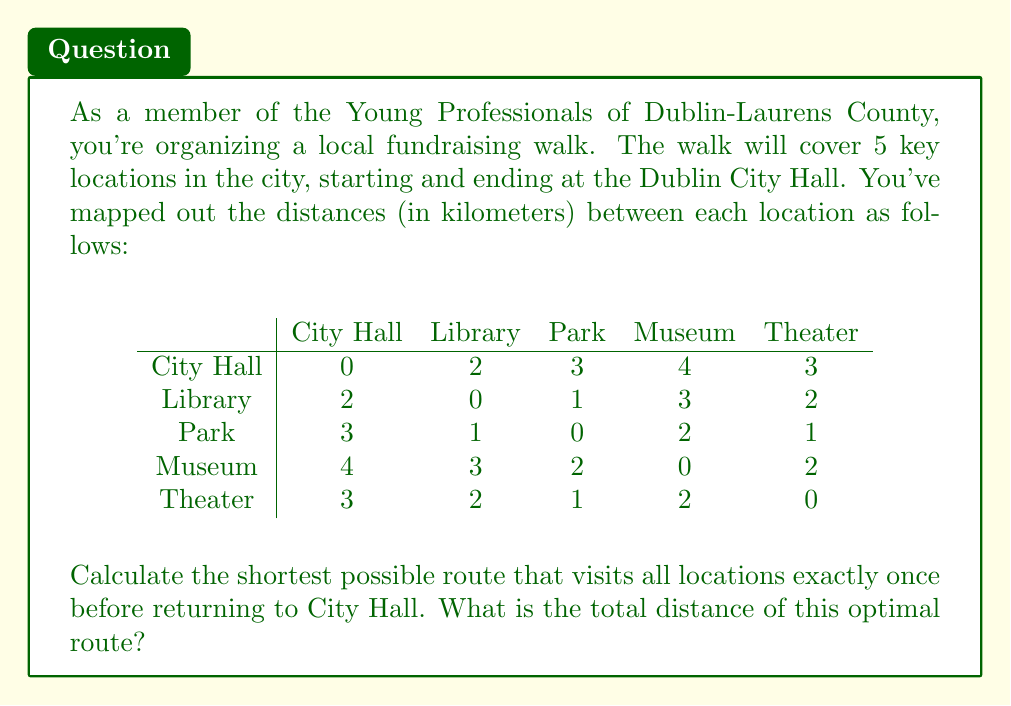Help me with this question. To solve this problem, we need to use the Traveling Salesman Problem (TSP) algorithm. Since we have a small number of locations, we can use the brute force approach to find the optimal solution.

Steps:

1) First, let's list all possible permutations of the 4 locations (excluding City Hall as it's the start and end point):

   Library -> Park -> Museum -> Theater
   Library -> Park -> Theater -> Museum
   Library -> Museum -> Park -> Theater
   Library -> Museum -> Theater -> Park
   Library -> Theater -> Park -> Museum
   Library -> Theater -> Museum -> Park
   Park -> Library -> Museum -> Theater
   Park -> Library -> Theater -> Museum
   Park -> Museum -> Library -> Theater
   Park -> Museum -> Theater -> Library
   Park -> Theater -> Library -> Museum
   Park -> Theater -> Museum -> Library
   Museum -> Library -> Park -> Theater
   Museum -> Library -> Theater -> Park
   Museum -> Park -> Library -> Theater
   Museum -> Park -> Theater -> Library
   Museum -> Theater -> Library -> Park
   Museum -> Theater -> Park -> Library
   Theater -> Library -> Park -> Museum
   Theater -> Library -> Museum -> Park
   Theater -> Park -> Library -> Museum
   Theater -> Park -> Museum -> Library
   Theater -> Museum -> Library -> Park
   Theater -> Museum -> Park -> Library

2) Now, for each permutation, we calculate the total distance:
   Distance = City Hall to First Location + Sum of distances between locations + Last Location to City Hall

3) Let's calculate for the first permutation as an example:
   City Hall -> Library -> Park -> Museum -> Theater -> City Hall
   Distance = 2 + 1 + 2 + 2 + 3 = 10 km

4) We repeat this process for all permutations and keep track of the minimum distance.

5) After checking all permutations, we find that the minimum distance is 10 km, which can be achieved by multiple routes, including:

   City Hall -> Library -> Park -> Museum -> Theater -> City Hall
   City Hall -> Theater -> Museum -> Park -> Library -> City Hall

Both of these routes (and their reverses) give the optimal distance of 10 km.
Answer: The shortest possible route that visits all locations exactly once before returning to City Hall is 10 km. 